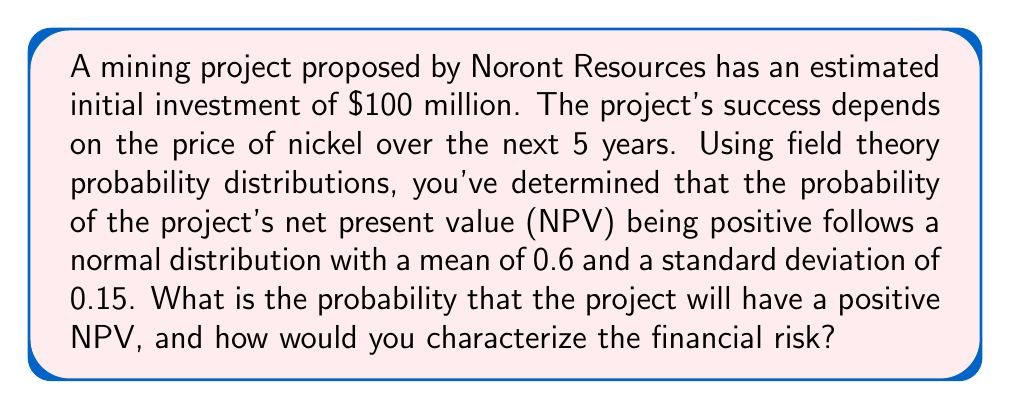Show me your answer to this math problem. To solve this problem, we'll use the properties of the normal distribution and the concept of z-scores.

Step 1: Identify the given information
- The probability of a positive NPV follows a normal distribution
- Mean (μ) = 0.6
- Standard deviation (σ) = 0.15
- We want to find P(NPV > 0), which is equivalent to P(X > 0.5) where X is the probability of positive NPV

Step 2: Calculate the z-score for the threshold value (0.5)
$$z = \frac{x - μ}{σ} = \frac{0.5 - 0.6}{0.15} = -\frac{1}{15} ≈ -0.6667$$

Step 3: Use a standard normal distribution table or calculator to find the area to the right of z
Area to the right of z = 1 - Φ(z), where Φ(z) is the cumulative distribution function
Using a calculator or table, we find:
1 - Φ(-0.6667) ≈ 0.7475

Step 4: Interpret the result
The probability that the project will have a positive NPV is approximately 0.7475 or 74.75%.

Step 5: Characterize the financial risk
To characterize the risk, we can consider the probability of a negative NPV, which is 1 - 0.7475 = 0.2525 or 25.25%.

A 25.25% chance of a negative NPV represents a moderate level of risk. While the project is more likely to be successful than not, there is still a significant chance of failure.
Answer: 74.75% probability of positive NPV; moderate financial risk 